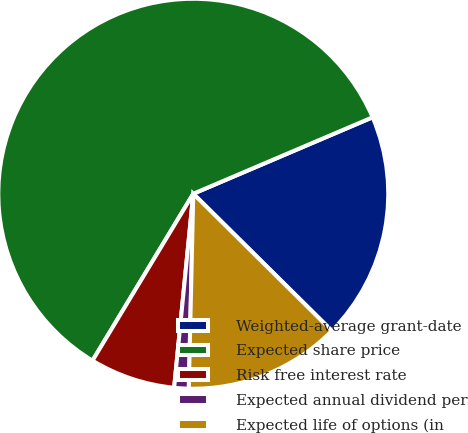<chart> <loc_0><loc_0><loc_500><loc_500><pie_chart><fcel>Weighted-average grant-date<fcel>Expected share price<fcel>Risk free interest rate<fcel>Expected annual dividend per<fcel>Expected life of options (in<nl><fcel>18.83%<fcel>59.94%<fcel>7.08%<fcel>1.2%<fcel>12.95%<nl></chart> 